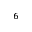Convert formula to latex. <formula><loc_0><loc_0><loc_500><loc_500>^ { 6 }</formula> 